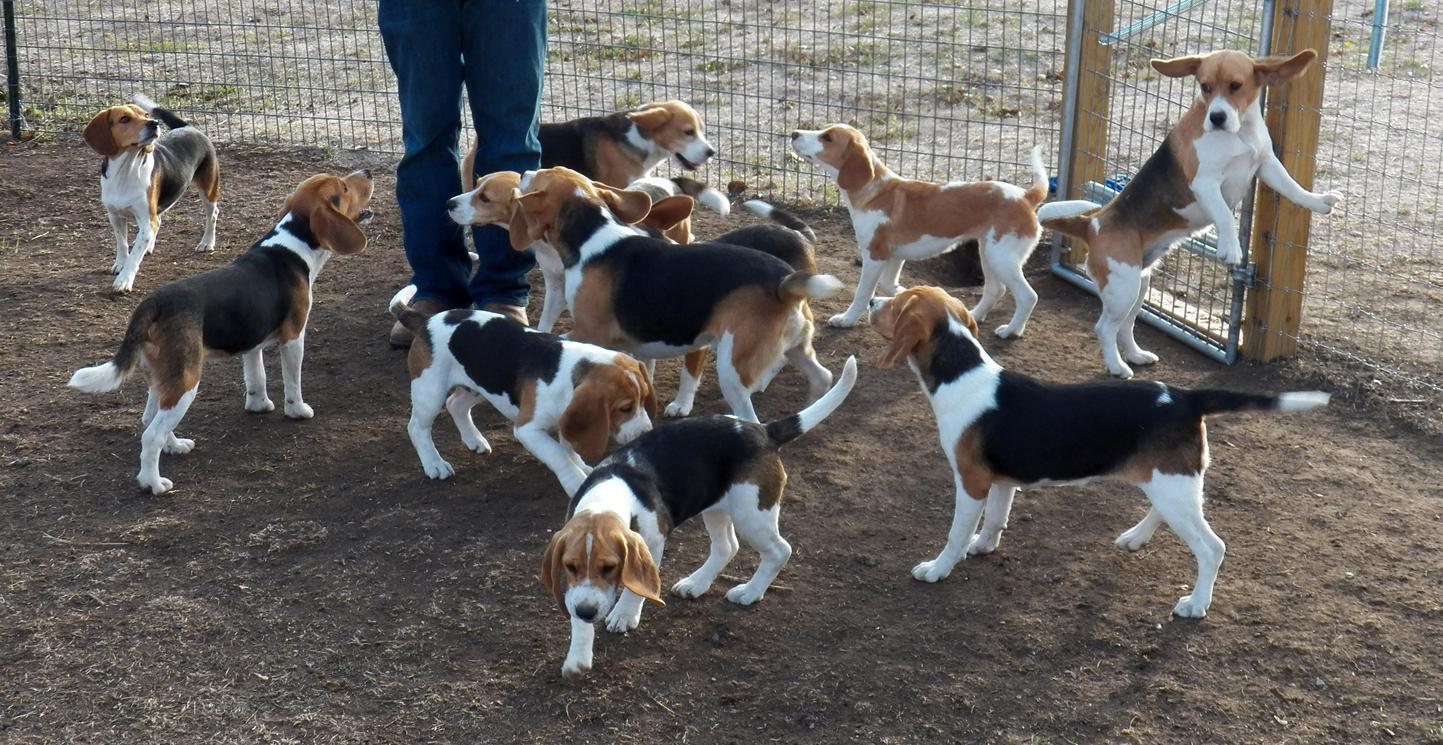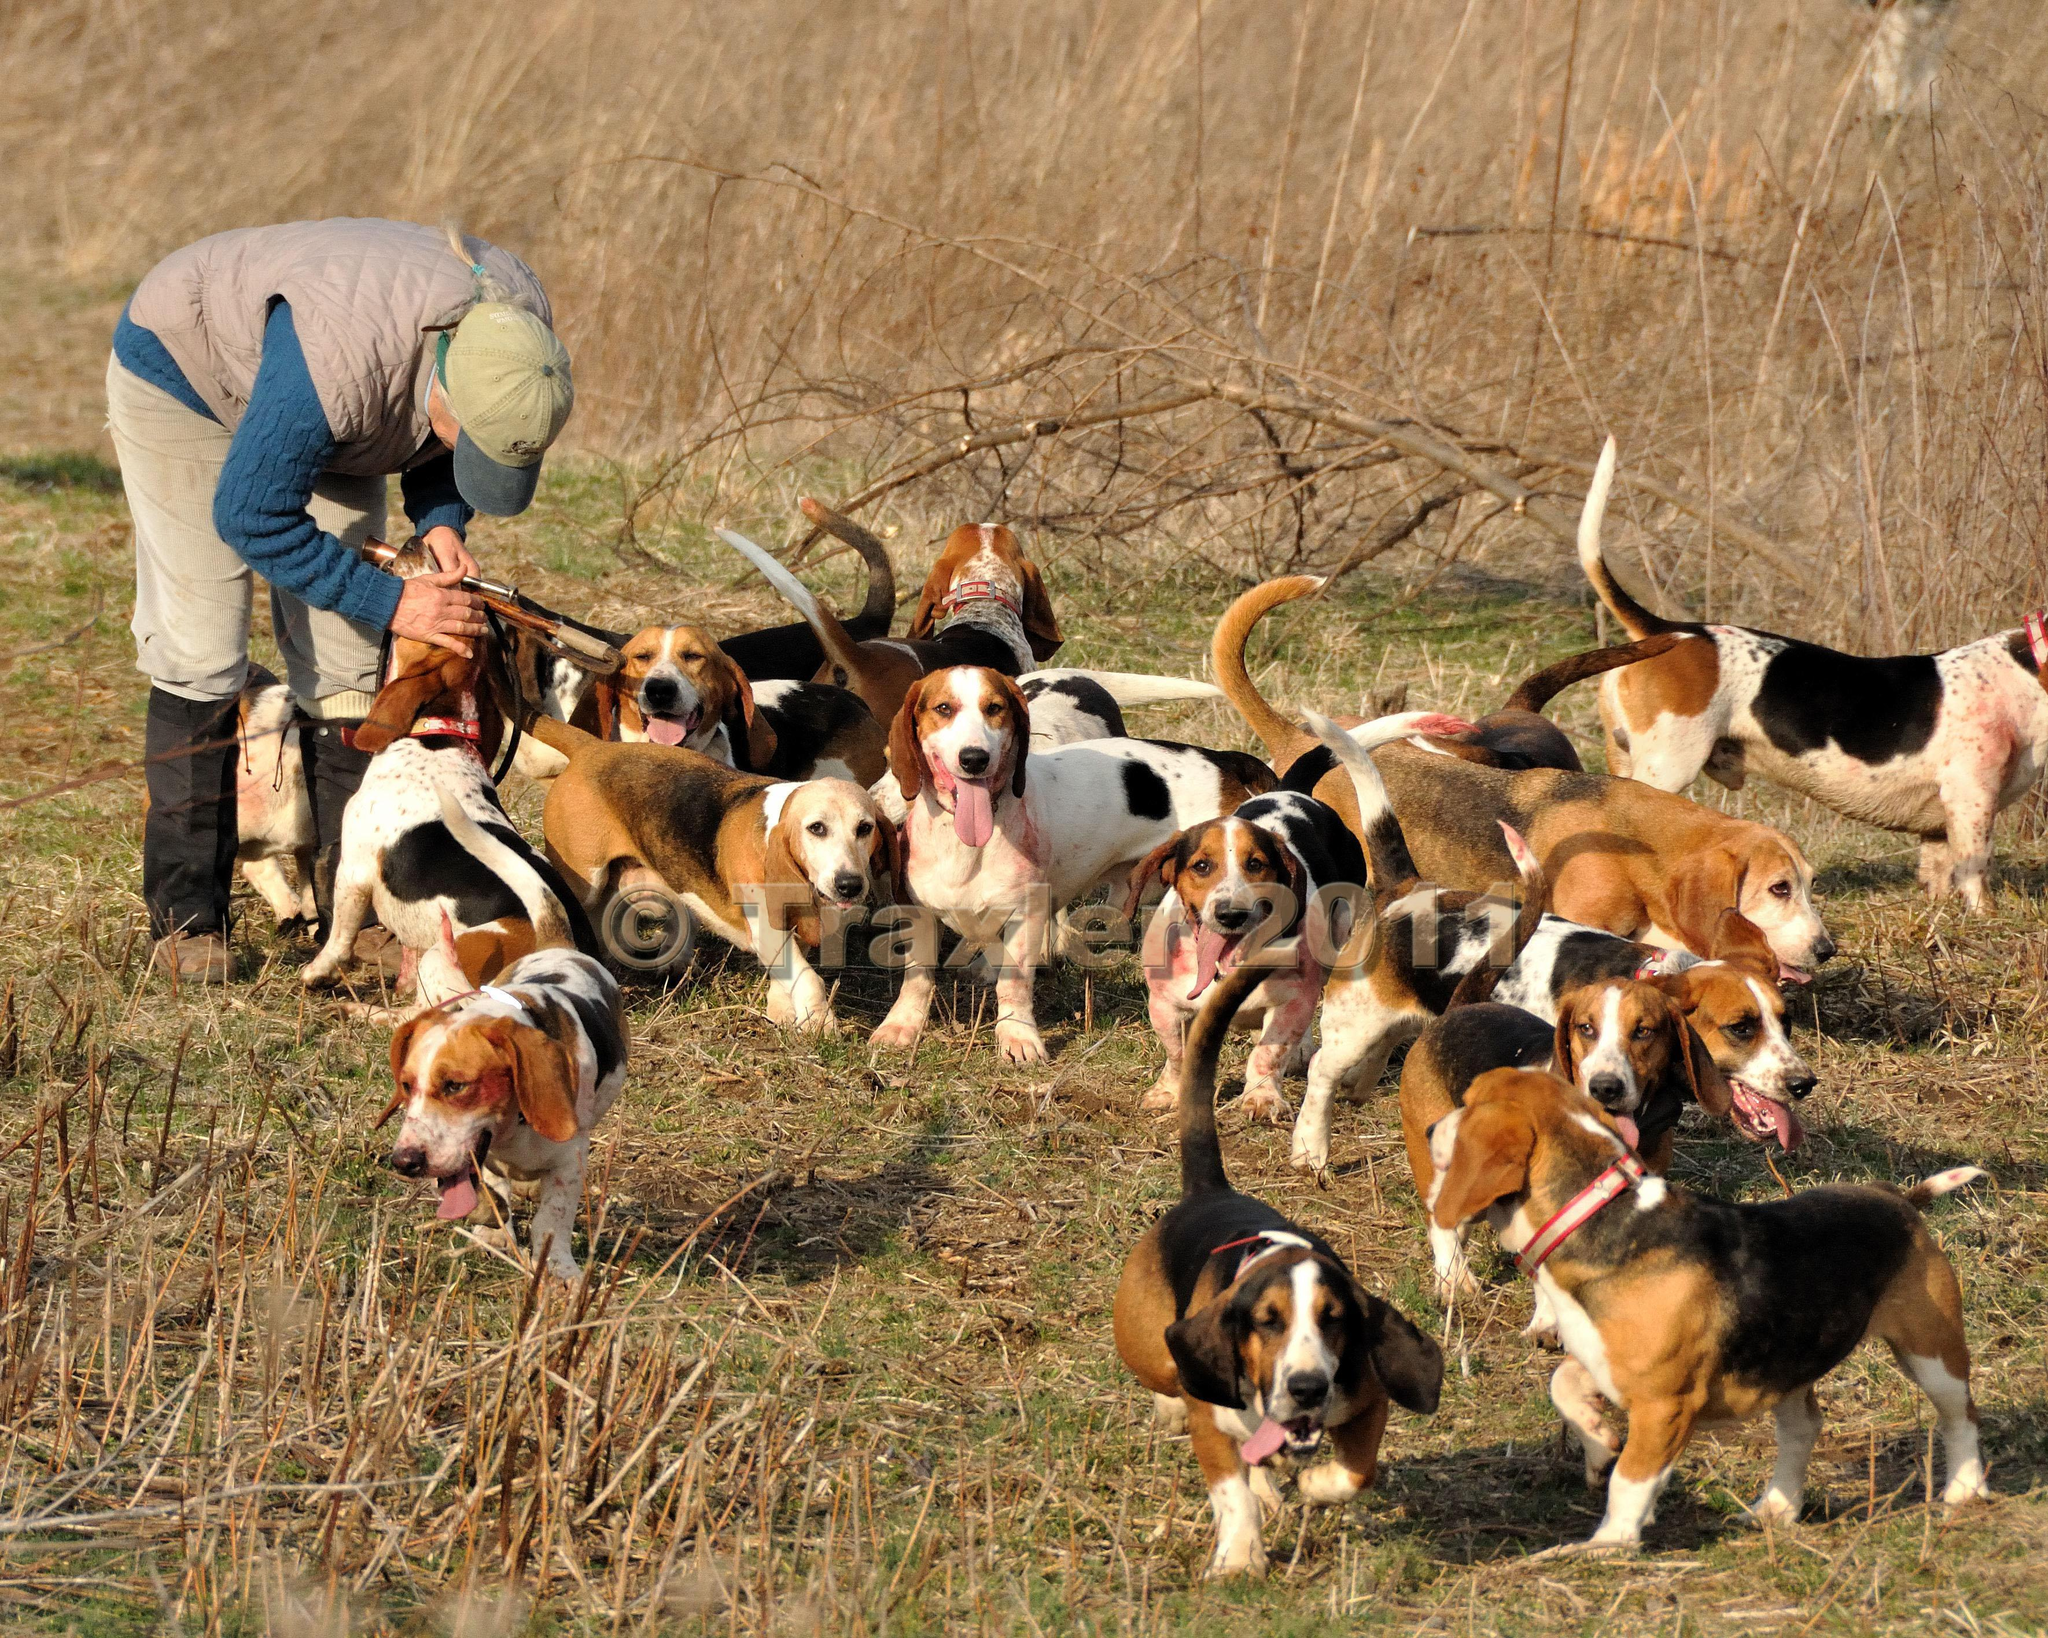The first image is the image on the left, the second image is the image on the right. Considering the images on both sides, is "Each image shows a pack of dogs near a man in a blazer and cap holding a whip stick." valid? Answer yes or no. No. The first image is the image on the left, the second image is the image on the right. For the images displayed, is the sentence "A white fence is visible behind a group of dogs." factually correct? Answer yes or no. No. 